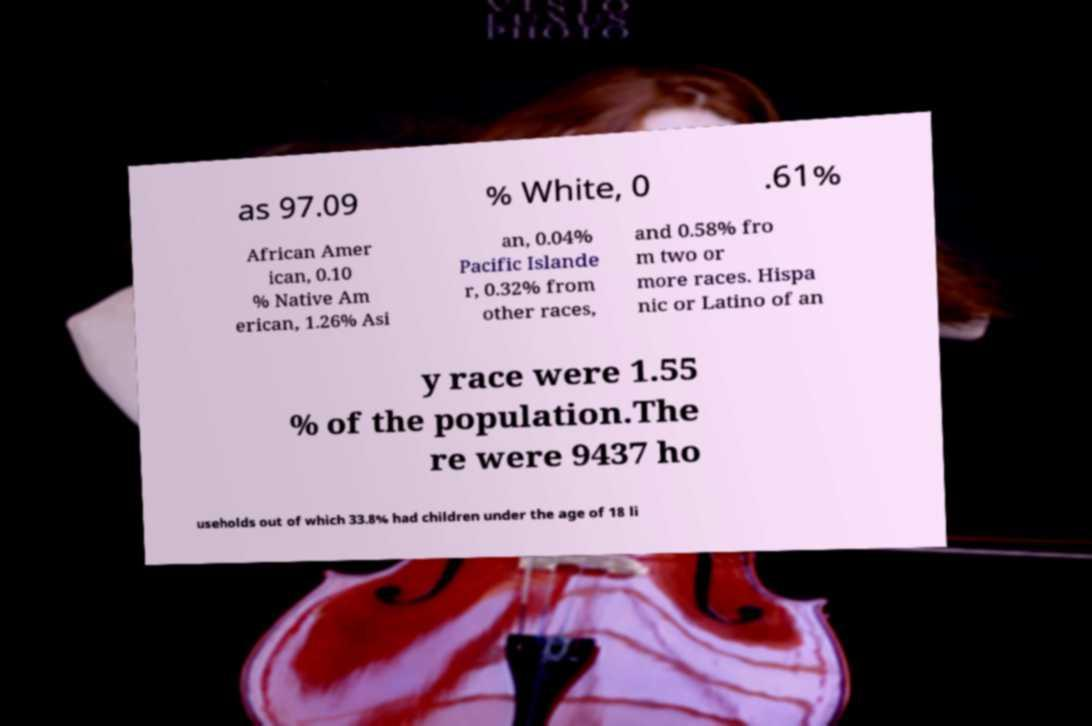Can you read and provide the text displayed in the image?This photo seems to have some interesting text. Can you extract and type it out for me? as 97.09 % White, 0 .61% African Amer ican, 0.10 % Native Am erican, 1.26% Asi an, 0.04% Pacific Islande r, 0.32% from other races, and 0.58% fro m two or more races. Hispa nic or Latino of an y race were 1.55 % of the population.The re were 9437 ho useholds out of which 33.8% had children under the age of 18 li 